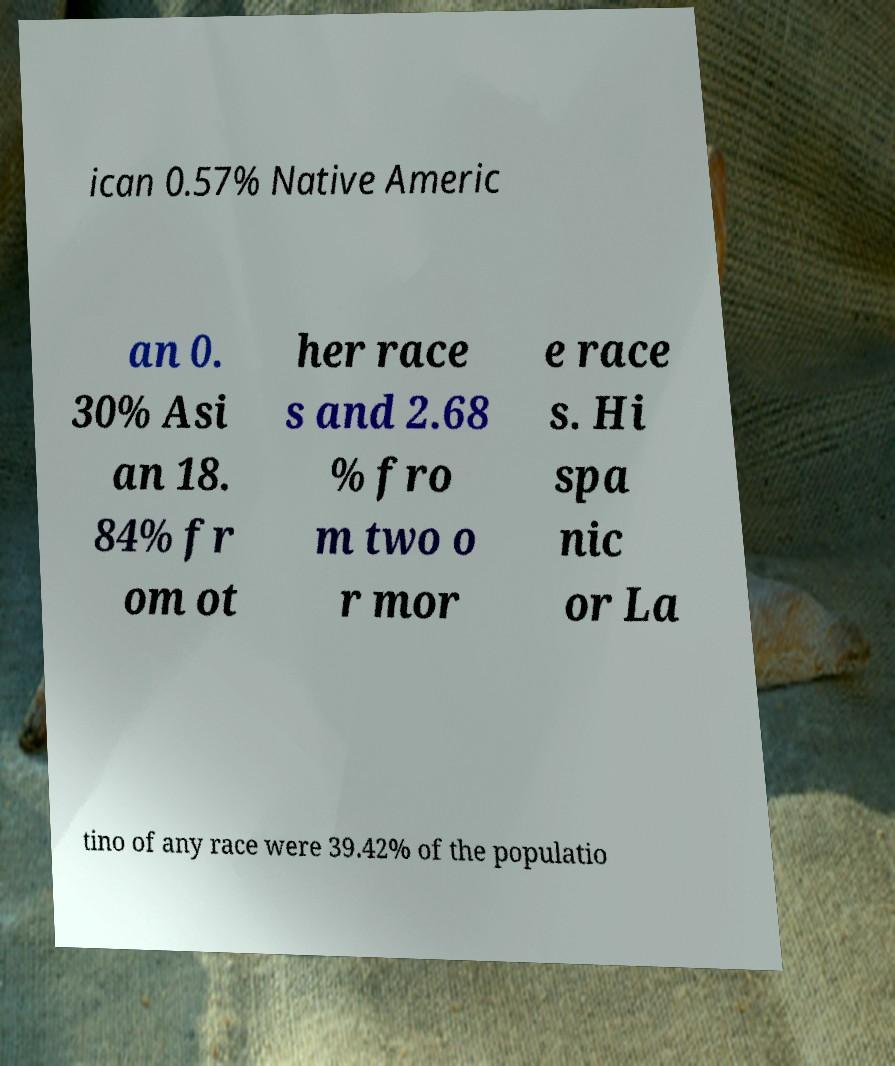I need the written content from this picture converted into text. Can you do that? ican 0.57% Native Americ an 0. 30% Asi an 18. 84% fr om ot her race s and 2.68 % fro m two o r mor e race s. Hi spa nic or La tino of any race were 39.42% of the populatio 